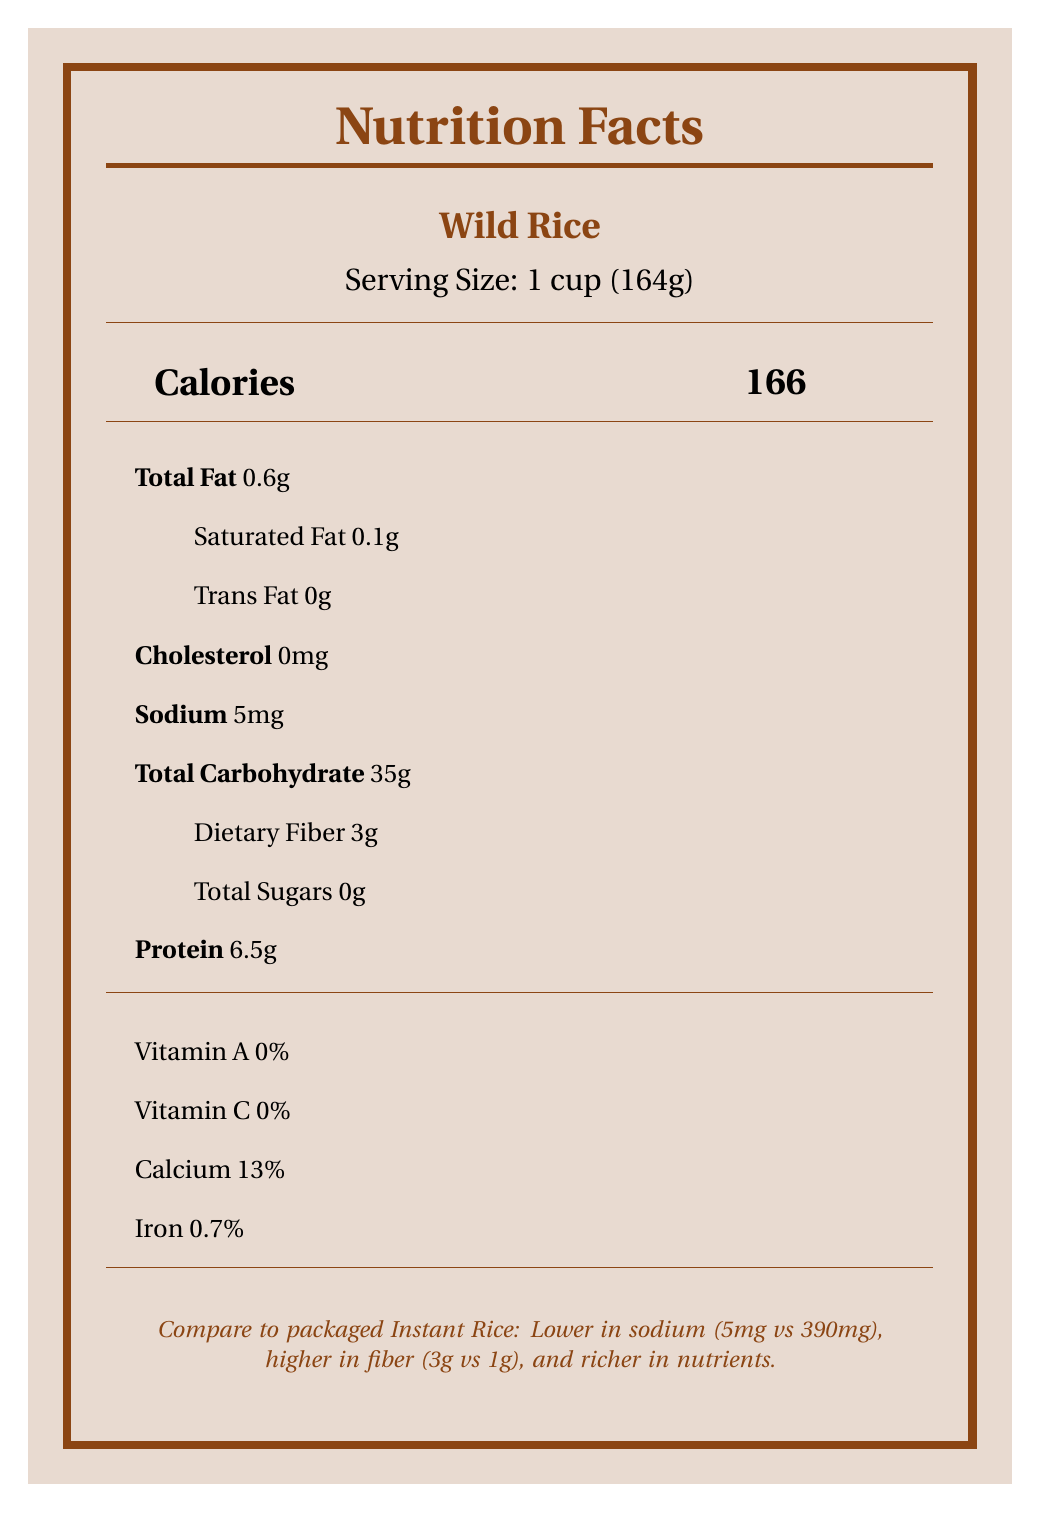what is the serving size for Wild Rice? The document lists the serving size for Wild Rice as "1 cup (164g)".
Answer: 1 cup (164g) how many calories are in a serving of Wild Rice? According to the document, a serving of Wild Rice contains 166 calories.
Answer: 166 what is the total fat content in Bison Meat? The document shows that Bison Meat has a total fat content of 7 grams per serving.
Answer: 7g how much dietary fiber does Instant Rice contain? As shown in the document, Instant Rice contains 1 gram of dietary fiber per serving.
Answer: 1g is there any trans fat in the traditional foods listed? The document specifies that the trans fat content for both Wild Rice and Bison Meat is 0 grams.
Answer: No which has more protein, Wild Rice or Instant Rice? The document indicates that Wild Rice has 6.5g of protein, while Instant Rice has 4g of protein.
Answer: Wild Rice how much iron does Beef Jerky contain per serving? According to the document, Beef Jerky contains 1.5mg of iron per serving.
Answer: 1.5mg which traditional food is higher in iron? 
A. Wild Rice 
B. Bison Meat 
C. Instant Rice 
D. Beef Jerky The document shows Bison Meat contains 3.5mg of iron per serving, which is the highest among the traditional foods listed.
Answer: B. Bison Meat which packaged food has the highest sodium content? 
A. Instant Rice 
B. Beef Jerky 
C. Both have the same amount Beef Jerky has 506mg of sodium, whereas Instant Rice contains 390mg.
Answer: B. Beef Jerky does Wild Rice contain any cholesterol? The document clearly states that Wild Rice contains 0mg of cholesterol.
Answer: No compare the fiber content: which food has a higher fiber content, Wild Rice or Instant Rice? The document states that Wild Rice has 3g of dietary fiber, compared to Instant Rice which has 1g.
Answer: Wild Rice summarize the main nutritional differences between Wild Rice and Instant Rice. Wild Rice has 166 calories, 5mg of sodium, 35g of carbohydrates, 3g of dietary fiber, and 6.5g of protein per serving. Instant Rice has 205 calories, 390mg of sodium, 45g of carbohydrates, 1g of dietary fiber, and 4g of protein per serving.
Answer: Wild Rice is lower in calories, sodium, and carbohydrates, but higher in dietary fiber and protein compared to Instant Rice. what is the total amount of saturated fat in Bison Meat and Beef Jerky combined? Bison Meat has 3g of saturated fat per serving, and Beef Jerky also has 3g of saturated fat per serving. The total is 6g.
Answer: 6g what is the primary health consideration noted in the document for traditional food options? The document highlights several health considerations but lists "Diabetes prevention through lower sugar intake" specifically for traditional food options.
Answer: Diabetes prevention through lower sugar intake how does the sodium content of Bison Meat compare to that of Beef Jerky? Bison Meat has 60mg of sodium per serving, whereas Beef Jerky contains 506mg of sodium per serving, making Bison Meat significantly lower in sodium.
Answer: Lower what is the reason for promoting the traditional foods over packaged alternatives in relation to heart health? The document indicates that traditional foods are promoted for heart health due to their lower sodium and saturated fat content.
Answer: Lower sodium and saturated fat content what is the vitamin A content in Bison Meat? The document states that Bison Meat contains 0% Vitamin A per serving.
Answer: 0% which food item does not have a specified sugar content? The document does not specify the sugar content for Bison Meat directly.
Answer: Not enough information how does Wild Rice contribute to digestion improvements? The document notes that Wild Rice has a higher fiber content, which aids in digestion.
Answer: Higher fiber content does the document mention the use of additives or preservatives in traditional foods? According to the document, traditional foods do not contain additives or preservatives.
Answer: No 